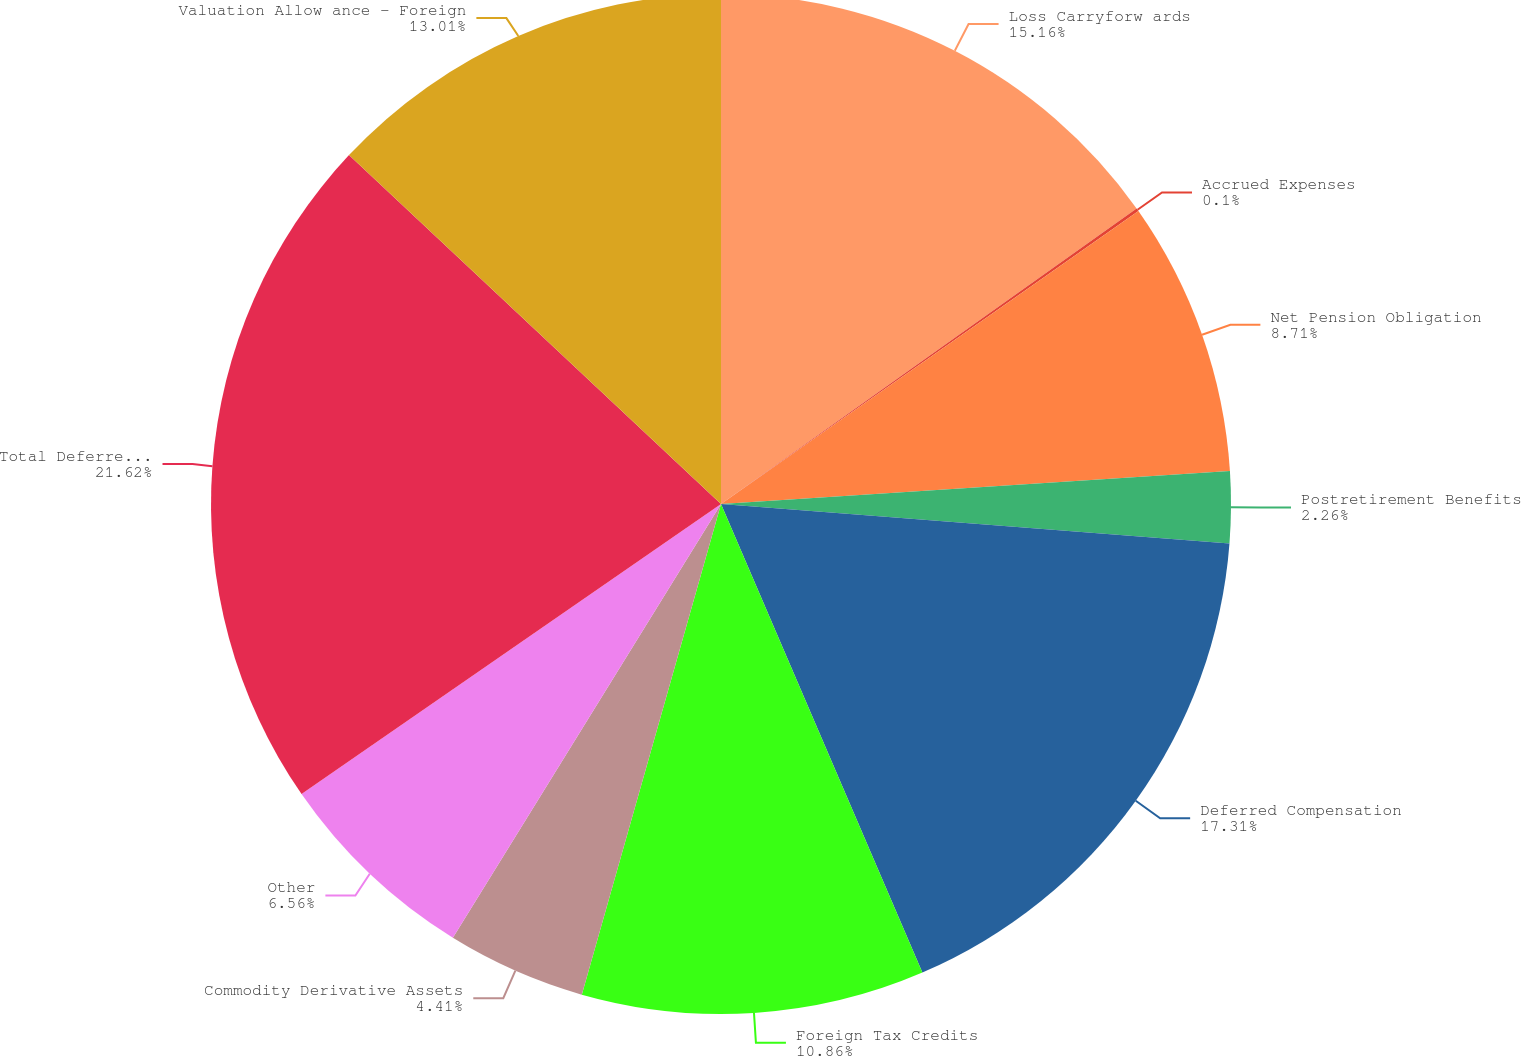<chart> <loc_0><loc_0><loc_500><loc_500><pie_chart><fcel>Loss Carryforw ards<fcel>Accrued Expenses<fcel>Net Pension Obligation<fcel>Postretirement Benefits<fcel>Deferred Compensation<fcel>Foreign Tax Credits<fcel>Commodity Derivative Assets<fcel>Other<fcel>Total Deferred Tax Assets<fcel>Valuation Allow ance - Foreign<nl><fcel>15.16%<fcel>0.1%<fcel>8.71%<fcel>2.26%<fcel>17.31%<fcel>10.86%<fcel>4.41%<fcel>6.56%<fcel>21.62%<fcel>13.01%<nl></chart> 